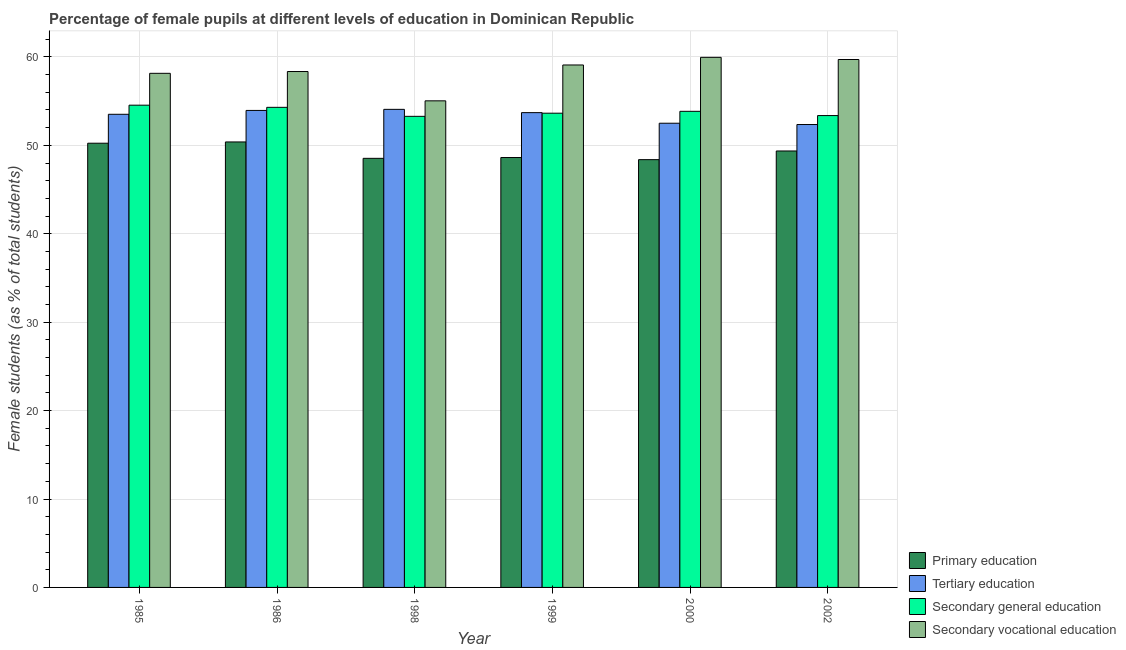How many different coloured bars are there?
Provide a succinct answer. 4. How many groups of bars are there?
Your answer should be very brief. 6. Are the number of bars per tick equal to the number of legend labels?
Ensure brevity in your answer.  Yes. How many bars are there on the 6th tick from the right?
Ensure brevity in your answer.  4. What is the percentage of female students in secondary vocational education in 2000?
Your response must be concise. 59.95. Across all years, what is the maximum percentage of female students in secondary education?
Give a very brief answer. 54.54. Across all years, what is the minimum percentage of female students in secondary vocational education?
Give a very brief answer. 55.03. In which year was the percentage of female students in secondary vocational education maximum?
Ensure brevity in your answer.  2000. In which year was the percentage of female students in tertiary education minimum?
Make the answer very short. 2002. What is the total percentage of female students in secondary education in the graph?
Your answer should be compact. 322.97. What is the difference between the percentage of female students in tertiary education in 1985 and that in 1999?
Your answer should be compact. -0.19. What is the difference between the percentage of female students in secondary vocational education in 2002 and the percentage of female students in primary education in 1999?
Your response must be concise. 0.62. What is the average percentage of female students in tertiary education per year?
Your response must be concise. 53.35. In how many years, is the percentage of female students in tertiary education greater than 24 %?
Offer a terse response. 6. What is the ratio of the percentage of female students in secondary vocational education in 1985 to that in 2000?
Offer a terse response. 0.97. Is the percentage of female students in secondary vocational education in 1985 less than that in 2000?
Offer a very short reply. Yes. What is the difference between the highest and the second highest percentage of female students in secondary education?
Offer a terse response. 0.24. What is the difference between the highest and the lowest percentage of female students in secondary education?
Offer a terse response. 1.26. Is the sum of the percentage of female students in tertiary education in 1998 and 2000 greater than the maximum percentage of female students in primary education across all years?
Offer a terse response. Yes. Is it the case that in every year, the sum of the percentage of female students in secondary education and percentage of female students in primary education is greater than the sum of percentage of female students in secondary vocational education and percentage of female students in tertiary education?
Keep it short and to the point. No. What does the 3rd bar from the left in 1999 represents?
Offer a very short reply. Secondary general education. What does the 1st bar from the right in 2000 represents?
Provide a short and direct response. Secondary vocational education. Is it the case that in every year, the sum of the percentage of female students in primary education and percentage of female students in tertiary education is greater than the percentage of female students in secondary education?
Make the answer very short. Yes. How many years are there in the graph?
Provide a short and direct response. 6. What is the difference between two consecutive major ticks on the Y-axis?
Ensure brevity in your answer.  10. Does the graph contain grids?
Your response must be concise. Yes. Where does the legend appear in the graph?
Your answer should be compact. Bottom right. How many legend labels are there?
Give a very brief answer. 4. How are the legend labels stacked?
Give a very brief answer. Vertical. What is the title of the graph?
Your response must be concise. Percentage of female pupils at different levels of education in Dominican Republic. What is the label or title of the X-axis?
Ensure brevity in your answer.  Year. What is the label or title of the Y-axis?
Your answer should be compact. Female students (as % of total students). What is the Female students (as % of total students) of Primary education in 1985?
Your answer should be compact. 50.24. What is the Female students (as % of total students) of Tertiary education in 1985?
Your answer should be compact. 53.51. What is the Female students (as % of total students) of Secondary general education in 1985?
Your answer should be very brief. 54.54. What is the Female students (as % of total students) in Secondary vocational education in 1985?
Offer a terse response. 58.14. What is the Female students (as % of total students) in Primary education in 1986?
Make the answer very short. 50.38. What is the Female students (as % of total students) of Tertiary education in 1986?
Keep it short and to the point. 53.95. What is the Female students (as % of total students) in Secondary general education in 1986?
Provide a succinct answer. 54.3. What is the Female students (as % of total students) of Secondary vocational education in 1986?
Offer a terse response. 58.35. What is the Female students (as % of total students) of Primary education in 1998?
Offer a very short reply. 48.53. What is the Female students (as % of total students) in Tertiary education in 1998?
Provide a succinct answer. 54.07. What is the Female students (as % of total students) in Secondary general education in 1998?
Your response must be concise. 53.28. What is the Female students (as % of total students) in Secondary vocational education in 1998?
Ensure brevity in your answer.  55.03. What is the Female students (as % of total students) of Primary education in 1999?
Give a very brief answer. 48.62. What is the Female students (as % of total students) in Tertiary education in 1999?
Offer a terse response. 53.7. What is the Female students (as % of total students) of Secondary general education in 1999?
Ensure brevity in your answer.  53.64. What is the Female students (as % of total students) in Secondary vocational education in 1999?
Keep it short and to the point. 59.09. What is the Female students (as % of total students) in Primary education in 2000?
Your response must be concise. 48.38. What is the Female students (as % of total students) in Tertiary education in 2000?
Offer a very short reply. 52.5. What is the Female students (as % of total students) in Secondary general education in 2000?
Your response must be concise. 53.85. What is the Female students (as % of total students) in Secondary vocational education in 2000?
Ensure brevity in your answer.  59.95. What is the Female students (as % of total students) in Primary education in 2002?
Offer a terse response. 49.36. What is the Female students (as % of total students) of Tertiary education in 2002?
Make the answer very short. 52.35. What is the Female students (as % of total students) in Secondary general education in 2002?
Provide a succinct answer. 53.37. What is the Female students (as % of total students) in Secondary vocational education in 2002?
Offer a very short reply. 59.71. Across all years, what is the maximum Female students (as % of total students) of Primary education?
Give a very brief answer. 50.38. Across all years, what is the maximum Female students (as % of total students) of Tertiary education?
Ensure brevity in your answer.  54.07. Across all years, what is the maximum Female students (as % of total students) in Secondary general education?
Provide a succinct answer. 54.54. Across all years, what is the maximum Female students (as % of total students) of Secondary vocational education?
Give a very brief answer. 59.95. Across all years, what is the minimum Female students (as % of total students) in Primary education?
Your answer should be very brief. 48.38. Across all years, what is the minimum Female students (as % of total students) of Tertiary education?
Your answer should be very brief. 52.35. Across all years, what is the minimum Female students (as % of total students) in Secondary general education?
Offer a very short reply. 53.28. Across all years, what is the minimum Female students (as % of total students) of Secondary vocational education?
Your response must be concise. 55.03. What is the total Female students (as % of total students) of Primary education in the graph?
Ensure brevity in your answer.  295.52. What is the total Female students (as % of total students) of Tertiary education in the graph?
Provide a succinct answer. 320.08. What is the total Female students (as % of total students) of Secondary general education in the graph?
Offer a terse response. 322.97. What is the total Female students (as % of total students) of Secondary vocational education in the graph?
Your answer should be compact. 350.27. What is the difference between the Female students (as % of total students) in Primary education in 1985 and that in 1986?
Provide a short and direct response. -0.14. What is the difference between the Female students (as % of total students) in Tertiary education in 1985 and that in 1986?
Give a very brief answer. -0.44. What is the difference between the Female students (as % of total students) in Secondary general education in 1985 and that in 1986?
Offer a terse response. 0.24. What is the difference between the Female students (as % of total students) in Secondary vocational education in 1985 and that in 1986?
Your answer should be very brief. -0.2. What is the difference between the Female students (as % of total students) in Primary education in 1985 and that in 1998?
Your answer should be compact. 1.71. What is the difference between the Female students (as % of total students) of Tertiary education in 1985 and that in 1998?
Make the answer very short. -0.56. What is the difference between the Female students (as % of total students) of Secondary general education in 1985 and that in 1998?
Provide a succinct answer. 1.26. What is the difference between the Female students (as % of total students) of Secondary vocational education in 1985 and that in 1998?
Keep it short and to the point. 3.11. What is the difference between the Female students (as % of total students) of Primary education in 1985 and that in 1999?
Your response must be concise. 1.62. What is the difference between the Female students (as % of total students) in Tertiary education in 1985 and that in 1999?
Provide a succinct answer. -0.19. What is the difference between the Female students (as % of total students) in Secondary general education in 1985 and that in 1999?
Keep it short and to the point. 0.91. What is the difference between the Female students (as % of total students) of Secondary vocational education in 1985 and that in 1999?
Provide a succinct answer. -0.94. What is the difference between the Female students (as % of total students) in Primary education in 1985 and that in 2000?
Your answer should be compact. 1.86. What is the difference between the Female students (as % of total students) of Tertiary education in 1985 and that in 2000?
Offer a very short reply. 1.01. What is the difference between the Female students (as % of total students) in Secondary general education in 1985 and that in 2000?
Offer a very short reply. 0.69. What is the difference between the Female students (as % of total students) in Secondary vocational education in 1985 and that in 2000?
Provide a short and direct response. -1.81. What is the difference between the Female students (as % of total students) of Primary education in 1985 and that in 2002?
Your answer should be very brief. 0.88. What is the difference between the Female students (as % of total students) of Tertiary education in 1985 and that in 2002?
Provide a succinct answer. 1.16. What is the difference between the Female students (as % of total students) of Secondary general education in 1985 and that in 2002?
Provide a short and direct response. 1.18. What is the difference between the Female students (as % of total students) of Secondary vocational education in 1985 and that in 2002?
Provide a succinct answer. -1.56. What is the difference between the Female students (as % of total students) in Primary education in 1986 and that in 1998?
Provide a short and direct response. 1.85. What is the difference between the Female students (as % of total students) of Tertiary education in 1986 and that in 1998?
Ensure brevity in your answer.  -0.12. What is the difference between the Female students (as % of total students) in Secondary general education in 1986 and that in 1998?
Keep it short and to the point. 1.02. What is the difference between the Female students (as % of total students) of Secondary vocational education in 1986 and that in 1998?
Your answer should be compact. 3.32. What is the difference between the Female students (as % of total students) of Primary education in 1986 and that in 1999?
Your answer should be very brief. 1.76. What is the difference between the Female students (as % of total students) of Tertiary education in 1986 and that in 1999?
Give a very brief answer. 0.25. What is the difference between the Female students (as % of total students) in Secondary general education in 1986 and that in 1999?
Offer a very short reply. 0.66. What is the difference between the Female students (as % of total students) in Secondary vocational education in 1986 and that in 1999?
Offer a very short reply. -0.74. What is the difference between the Female students (as % of total students) of Primary education in 1986 and that in 2000?
Keep it short and to the point. 2. What is the difference between the Female students (as % of total students) in Tertiary education in 1986 and that in 2000?
Your answer should be compact. 1.45. What is the difference between the Female students (as % of total students) in Secondary general education in 1986 and that in 2000?
Your response must be concise. 0.45. What is the difference between the Female students (as % of total students) of Secondary vocational education in 1986 and that in 2000?
Ensure brevity in your answer.  -1.6. What is the difference between the Female students (as % of total students) of Primary education in 1986 and that in 2002?
Keep it short and to the point. 1.02. What is the difference between the Female students (as % of total students) of Tertiary education in 1986 and that in 2002?
Offer a very short reply. 1.59. What is the difference between the Female students (as % of total students) of Secondary general education in 1986 and that in 2002?
Your answer should be very brief. 0.93. What is the difference between the Female students (as % of total students) of Secondary vocational education in 1986 and that in 2002?
Your response must be concise. -1.36. What is the difference between the Female students (as % of total students) in Primary education in 1998 and that in 1999?
Keep it short and to the point. -0.09. What is the difference between the Female students (as % of total students) of Tertiary education in 1998 and that in 1999?
Ensure brevity in your answer.  0.37. What is the difference between the Female students (as % of total students) in Secondary general education in 1998 and that in 1999?
Offer a very short reply. -0.36. What is the difference between the Female students (as % of total students) of Secondary vocational education in 1998 and that in 1999?
Give a very brief answer. -4.06. What is the difference between the Female students (as % of total students) of Primary education in 1998 and that in 2000?
Offer a terse response. 0.15. What is the difference between the Female students (as % of total students) in Tertiary education in 1998 and that in 2000?
Provide a short and direct response. 1.57. What is the difference between the Female students (as % of total students) in Secondary general education in 1998 and that in 2000?
Your answer should be compact. -0.57. What is the difference between the Female students (as % of total students) of Secondary vocational education in 1998 and that in 2000?
Offer a very short reply. -4.92. What is the difference between the Female students (as % of total students) of Primary education in 1998 and that in 2002?
Keep it short and to the point. -0.83. What is the difference between the Female students (as % of total students) in Tertiary education in 1998 and that in 2002?
Provide a succinct answer. 1.72. What is the difference between the Female students (as % of total students) in Secondary general education in 1998 and that in 2002?
Your answer should be compact. -0.09. What is the difference between the Female students (as % of total students) of Secondary vocational education in 1998 and that in 2002?
Give a very brief answer. -4.67. What is the difference between the Female students (as % of total students) in Primary education in 1999 and that in 2000?
Give a very brief answer. 0.24. What is the difference between the Female students (as % of total students) in Tertiary education in 1999 and that in 2000?
Offer a terse response. 1.2. What is the difference between the Female students (as % of total students) in Secondary general education in 1999 and that in 2000?
Give a very brief answer. -0.21. What is the difference between the Female students (as % of total students) of Secondary vocational education in 1999 and that in 2000?
Your response must be concise. -0.86. What is the difference between the Female students (as % of total students) in Primary education in 1999 and that in 2002?
Ensure brevity in your answer.  -0.74. What is the difference between the Female students (as % of total students) of Tertiary education in 1999 and that in 2002?
Your response must be concise. 1.34. What is the difference between the Female students (as % of total students) of Secondary general education in 1999 and that in 2002?
Provide a succinct answer. 0.27. What is the difference between the Female students (as % of total students) in Secondary vocational education in 1999 and that in 2002?
Give a very brief answer. -0.62. What is the difference between the Female students (as % of total students) in Primary education in 2000 and that in 2002?
Ensure brevity in your answer.  -0.98. What is the difference between the Female students (as % of total students) of Tertiary education in 2000 and that in 2002?
Your answer should be compact. 0.15. What is the difference between the Female students (as % of total students) of Secondary general education in 2000 and that in 2002?
Provide a succinct answer. 0.48. What is the difference between the Female students (as % of total students) of Secondary vocational education in 2000 and that in 2002?
Provide a succinct answer. 0.25. What is the difference between the Female students (as % of total students) in Primary education in 1985 and the Female students (as % of total students) in Tertiary education in 1986?
Offer a terse response. -3.71. What is the difference between the Female students (as % of total students) of Primary education in 1985 and the Female students (as % of total students) of Secondary general education in 1986?
Provide a short and direct response. -4.06. What is the difference between the Female students (as % of total students) of Primary education in 1985 and the Female students (as % of total students) of Secondary vocational education in 1986?
Provide a succinct answer. -8.11. What is the difference between the Female students (as % of total students) in Tertiary education in 1985 and the Female students (as % of total students) in Secondary general education in 1986?
Provide a succinct answer. -0.79. What is the difference between the Female students (as % of total students) in Tertiary education in 1985 and the Female students (as % of total students) in Secondary vocational education in 1986?
Ensure brevity in your answer.  -4.84. What is the difference between the Female students (as % of total students) in Secondary general education in 1985 and the Female students (as % of total students) in Secondary vocational education in 1986?
Offer a very short reply. -3.81. What is the difference between the Female students (as % of total students) in Primary education in 1985 and the Female students (as % of total students) in Tertiary education in 1998?
Offer a terse response. -3.83. What is the difference between the Female students (as % of total students) of Primary education in 1985 and the Female students (as % of total students) of Secondary general education in 1998?
Provide a short and direct response. -3.04. What is the difference between the Female students (as % of total students) in Primary education in 1985 and the Female students (as % of total students) in Secondary vocational education in 1998?
Ensure brevity in your answer.  -4.79. What is the difference between the Female students (as % of total students) in Tertiary education in 1985 and the Female students (as % of total students) in Secondary general education in 1998?
Your response must be concise. 0.23. What is the difference between the Female students (as % of total students) in Tertiary education in 1985 and the Female students (as % of total students) in Secondary vocational education in 1998?
Keep it short and to the point. -1.52. What is the difference between the Female students (as % of total students) in Secondary general education in 1985 and the Female students (as % of total students) in Secondary vocational education in 1998?
Your answer should be very brief. -0.49. What is the difference between the Female students (as % of total students) in Primary education in 1985 and the Female students (as % of total students) in Tertiary education in 1999?
Ensure brevity in your answer.  -3.46. What is the difference between the Female students (as % of total students) of Primary education in 1985 and the Female students (as % of total students) of Secondary general education in 1999?
Provide a short and direct response. -3.4. What is the difference between the Female students (as % of total students) of Primary education in 1985 and the Female students (as % of total students) of Secondary vocational education in 1999?
Your answer should be very brief. -8.85. What is the difference between the Female students (as % of total students) of Tertiary education in 1985 and the Female students (as % of total students) of Secondary general education in 1999?
Give a very brief answer. -0.12. What is the difference between the Female students (as % of total students) in Tertiary education in 1985 and the Female students (as % of total students) in Secondary vocational education in 1999?
Offer a very short reply. -5.58. What is the difference between the Female students (as % of total students) in Secondary general education in 1985 and the Female students (as % of total students) in Secondary vocational education in 1999?
Your response must be concise. -4.55. What is the difference between the Female students (as % of total students) in Primary education in 1985 and the Female students (as % of total students) in Tertiary education in 2000?
Your response must be concise. -2.26. What is the difference between the Female students (as % of total students) of Primary education in 1985 and the Female students (as % of total students) of Secondary general education in 2000?
Your answer should be compact. -3.61. What is the difference between the Female students (as % of total students) in Primary education in 1985 and the Female students (as % of total students) in Secondary vocational education in 2000?
Your answer should be very brief. -9.71. What is the difference between the Female students (as % of total students) of Tertiary education in 1985 and the Female students (as % of total students) of Secondary general education in 2000?
Your response must be concise. -0.34. What is the difference between the Female students (as % of total students) in Tertiary education in 1985 and the Female students (as % of total students) in Secondary vocational education in 2000?
Give a very brief answer. -6.44. What is the difference between the Female students (as % of total students) in Secondary general education in 1985 and the Female students (as % of total students) in Secondary vocational education in 2000?
Your answer should be very brief. -5.41. What is the difference between the Female students (as % of total students) in Primary education in 1985 and the Female students (as % of total students) in Tertiary education in 2002?
Ensure brevity in your answer.  -2.11. What is the difference between the Female students (as % of total students) of Primary education in 1985 and the Female students (as % of total students) of Secondary general education in 2002?
Ensure brevity in your answer.  -3.13. What is the difference between the Female students (as % of total students) of Primary education in 1985 and the Female students (as % of total students) of Secondary vocational education in 2002?
Keep it short and to the point. -9.47. What is the difference between the Female students (as % of total students) of Tertiary education in 1985 and the Female students (as % of total students) of Secondary general education in 2002?
Make the answer very short. 0.15. What is the difference between the Female students (as % of total students) in Tertiary education in 1985 and the Female students (as % of total students) in Secondary vocational education in 2002?
Your response must be concise. -6.19. What is the difference between the Female students (as % of total students) of Secondary general education in 1985 and the Female students (as % of total students) of Secondary vocational education in 2002?
Your answer should be compact. -5.16. What is the difference between the Female students (as % of total students) in Primary education in 1986 and the Female students (as % of total students) in Tertiary education in 1998?
Keep it short and to the point. -3.69. What is the difference between the Female students (as % of total students) of Primary education in 1986 and the Female students (as % of total students) of Secondary general education in 1998?
Your answer should be compact. -2.9. What is the difference between the Female students (as % of total students) in Primary education in 1986 and the Female students (as % of total students) in Secondary vocational education in 1998?
Make the answer very short. -4.65. What is the difference between the Female students (as % of total students) in Tertiary education in 1986 and the Female students (as % of total students) in Secondary general education in 1998?
Keep it short and to the point. 0.67. What is the difference between the Female students (as % of total students) of Tertiary education in 1986 and the Female students (as % of total students) of Secondary vocational education in 1998?
Your response must be concise. -1.08. What is the difference between the Female students (as % of total students) of Secondary general education in 1986 and the Female students (as % of total students) of Secondary vocational education in 1998?
Make the answer very short. -0.73. What is the difference between the Female students (as % of total students) in Primary education in 1986 and the Female students (as % of total students) in Tertiary education in 1999?
Offer a terse response. -3.32. What is the difference between the Female students (as % of total students) of Primary education in 1986 and the Female students (as % of total students) of Secondary general education in 1999?
Give a very brief answer. -3.25. What is the difference between the Female students (as % of total students) of Primary education in 1986 and the Female students (as % of total students) of Secondary vocational education in 1999?
Make the answer very short. -8.71. What is the difference between the Female students (as % of total students) of Tertiary education in 1986 and the Female students (as % of total students) of Secondary general education in 1999?
Give a very brief answer. 0.31. What is the difference between the Female students (as % of total students) in Tertiary education in 1986 and the Female students (as % of total students) in Secondary vocational education in 1999?
Give a very brief answer. -5.14. What is the difference between the Female students (as % of total students) in Secondary general education in 1986 and the Female students (as % of total students) in Secondary vocational education in 1999?
Offer a terse response. -4.79. What is the difference between the Female students (as % of total students) in Primary education in 1986 and the Female students (as % of total students) in Tertiary education in 2000?
Your response must be concise. -2.12. What is the difference between the Female students (as % of total students) in Primary education in 1986 and the Female students (as % of total students) in Secondary general education in 2000?
Give a very brief answer. -3.46. What is the difference between the Female students (as % of total students) of Primary education in 1986 and the Female students (as % of total students) of Secondary vocational education in 2000?
Offer a very short reply. -9.57. What is the difference between the Female students (as % of total students) in Tertiary education in 1986 and the Female students (as % of total students) in Secondary general education in 2000?
Your response must be concise. 0.1. What is the difference between the Female students (as % of total students) of Tertiary education in 1986 and the Female students (as % of total students) of Secondary vocational education in 2000?
Provide a short and direct response. -6.01. What is the difference between the Female students (as % of total students) in Secondary general education in 1986 and the Female students (as % of total students) in Secondary vocational education in 2000?
Your answer should be very brief. -5.65. What is the difference between the Female students (as % of total students) in Primary education in 1986 and the Female students (as % of total students) in Tertiary education in 2002?
Provide a succinct answer. -1.97. What is the difference between the Female students (as % of total students) in Primary education in 1986 and the Female students (as % of total students) in Secondary general education in 2002?
Keep it short and to the point. -2.98. What is the difference between the Female students (as % of total students) of Primary education in 1986 and the Female students (as % of total students) of Secondary vocational education in 2002?
Offer a terse response. -9.32. What is the difference between the Female students (as % of total students) of Tertiary education in 1986 and the Female students (as % of total students) of Secondary general education in 2002?
Provide a succinct answer. 0.58. What is the difference between the Female students (as % of total students) in Tertiary education in 1986 and the Female students (as % of total students) in Secondary vocational education in 2002?
Provide a short and direct response. -5.76. What is the difference between the Female students (as % of total students) in Secondary general education in 1986 and the Female students (as % of total students) in Secondary vocational education in 2002?
Give a very brief answer. -5.41. What is the difference between the Female students (as % of total students) in Primary education in 1998 and the Female students (as % of total students) in Tertiary education in 1999?
Provide a succinct answer. -5.17. What is the difference between the Female students (as % of total students) of Primary education in 1998 and the Female students (as % of total students) of Secondary general education in 1999?
Your response must be concise. -5.1. What is the difference between the Female students (as % of total students) of Primary education in 1998 and the Female students (as % of total students) of Secondary vocational education in 1999?
Provide a short and direct response. -10.56. What is the difference between the Female students (as % of total students) of Tertiary education in 1998 and the Female students (as % of total students) of Secondary general education in 1999?
Offer a very short reply. 0.44. What is the difference between the Female students (as % of total students) in Tertiary education in 1998 and the Female students (as % of total students) in Secondary vocational education in 1999?
Make the answer very short. -5.02. What is the difference between the Female students (as % of total students) in Secondary general education in 1998 and the Female students (as % of total students) in Secondary vocational education in 1999?
Provide a succinct answer. -5.81. What is the difference between the Female students (as % of total students) in Primary education in 1998 and the Female students (as % of total students) in Tertiary education in 2000?
Offer a very short reply. -3.97. What is the difference between the Female students (as % of total students) of Primary education in 1998 and the Female students (as % of total students) of Secondary general education in 2000?
Offer a terse response. -5.32. What is the difference between the Female students (as % of total students) of Primary education in 1998 and the Female students (as % of total students) of Secondary vocational education in 2000?
Ensure brevity in your answer.  -11.42. What is the difference between the Female students (as % of total students) of Tertiary education in 1998 and the Female students (as % of total students) of Secondary general education in 2000?
Your answer should be very brief. 0.22. What is the difference between the Female students (as % of total students) in Tertiary education in 1998 and the Female students (as % of total students) in Secondary vocational education in 2000?
Make the answer very short. -5.88. What is the difference between the Female students (as % of total students) of Secondary general education in 1998 and the Female students (as % of total students) of Secondary vocational education in 2000?
Give a very brief answer. -6.67. What is the difference between the Female students (as % of total students) of Primary education in 1998 and the Female students (as % of total students) of Tertiary education in 2002?
Your answer should be very brief. -3.82. What is the difference between the Female students (as % of total students) in Primary education in 1998 and the Female students (as % of total students) in Secondary general education in 2002?
Offer a very short reply. -4.84. What is the difference between the Female students (as % of total students) of Primary education in 1998 and the Female students (as % of total students) of Secondary vocational education in 2002?
Provide a succinct answer. -11.18. What is the difference between the Female students (as % of total students) of Tertiary education in 1998 and the Female students (as % of total students) of Secondary general education in 2002?
Your response must be concise. 0.7. What is the difference between the Female students (as % of total students) of Tertiary education in 1998 and the Female students (as % of total students) of Secondary vocational education in 2002?
Keep it short and to the point. -5.64. What is the difference between the Female students (as % of total students) of Secondary general education in 1998 and the Female students (as % of total students) of Secondary vocational education in 2002?
Offer a very short reply. -6.43. What is the difference between the Female students (as % of total students) of Primary education in 1999 and the Female students (as % of total students) of Tertiary education in 2000?
Offer a terse response. -3.88. What is the difference between the Female students (as % of total students) of Primary education in 1999 and the Female students (as % of total students) of Secondary general education in 2000?
Your response must be concise. -5.23. What is the difference between the Female students (as % of total students) of Primary education in 1999 and the Female students (as % of total students) of Secondary vocational education in 2000?
Your response must be concise. -11.33. What is the difference between the Female students (as % of total students) in Tertiary education in 1999 and the Female students (as % of total students) in Secondary general education in 2000?
Your answer should be very brief. -0.15. What is the difference between the Female students (as % of total students) of Tertiary education in 1999 and the Female students (as % of total students) of Secondary vocational education in 2000?
Ensure brevity in your answer.  -6.25. What is the difference between the Female students (as % of total students) in Secondary general education in 1999 and the Female students (as % of total students) in Secondary vocational education in 2000?
Give a very brief answer. -6.32. What is the difference between the Female students (as % of total students) of Primary education in 1999 and the Female students (as % of total students) of Tertiary education in 2002?
Keep it short and to the point. -3.73. What is the difference between the Female students (as % of total students) in Primary education in 1999 and the Female students (as % of total students) in Secondary general education in 2002?
Provide a succinct answer. -4.75. What is the difference between the Female students (as % of total students) in Primary education in 1999 and the Female students (as % of total students) in Secondary vocational education in 2002?
Your answer should be very brief. -11.09. What is the difference between the Female students (as % of total students) of Tertiary education in 1999 and the Female students (as % of total students) of Secondary general education in 2002?
Ensure brevity in your answer.  0.33. What is the difference between the Female students (as % of total students) in Tertiary education in 1999 and the Female students (as % of total students) in Secondary vocational education in 2002?
Give a very brief answer. -6.01. What is the difference between the Female students (as % of total students) in Secondary general education in 1999 and the Female students (as % of total students) in Secondary vocational education in 2002?
Your response must be concise. -6.07. What is the difference between the Female students (as % of total students) of Primary education in 2000 and the Female students (as % of total students) of Tertiary education in 2002?
Ensure brevity in your answer.  -3.97. What is the difference between the Female students (as % of total students) of Primary education in 2000 and the Female students (as % of total students) of Secondary general education in 2002?
Offer a very short reply. -4.98. What is the difference between the Female students (as % of total students) in Primary education in 2000 and the Female students (as % of total students) in Secondary vocational education in 2002?
Offer a very short reply. -11.32. What is the difference between the Female students (as % of total students) of Tertiary education in 2000 and the Female students (as % of total students) of Secondary general education in 2002?
Offer a very short reply. -0.87. What is the difference between the Female students (as % of total students) in Tertiary education in 2000 and the Female students (as % of total students) in Secondary vocational education in 2002?
Your response must be concise. -7.21. What is the difference between the Female students (as % of total students) of Secondary general education in 2000 and the Female students (as % of total students) of Secondary vocational education in 2002?
Provide a short and direct response. -5.86. What is the average Female students (as % of total students) in Primary education per year?
Give a very brief answer. 49.25. What is the average Female students (as % of total students) of Tertiary education per year?
Provide a succinct answer. 53.35. What is the average Female students (as % of total students) of Secondary general education per year?
Provide a short and direct response. 53.83. What is the average Female students (as % of total students) in Secondary vocational education per year?
Your response must be concise. 58.38. In the year 1985, what is the difference between the Female students (as % of total students) of Primary education and Female students (as % of total students) of Tertiary education?
Your response must be concise. -3.27. In the year 1985, what is the difference between the Female students (as % of total students) in Primary education and Female students (as % of total students) in Secondary general education?
Offer a terse response. -4.3. In the year 1985, what is the difference between the Female students (as % of total students) in Primary education and Female students (as % of total students) in Secondary vocational education?
Give a very brief answer. -7.9. In the year 1985, what is the difference between the Female students (as % of total students) in Tertiary education and Female students (as % of total students) in Secondary general education?
Your response must be concise. -1.03. In the year 1985, what is the difference between the Female students (as % of total students) of Tertiary education and Female students (as % of total students) of Secondary vocational education?
Ensure brevity in your answer.  -4.63. In the year 1985, what is the difference between the Female students (as % of total students) of Secondary general education and Female students (as % of total students) of Secondary vocational education?
Provide a short and direct response. -3.6. In the year 1986, what is the difference between the Female students (as % of total students) of Primary education and Female students (as % of total students) of Tertiary education?
Provide a short and direct response. -3.56. In the year 1986, what is the difference between the Female students (as % of total students) in Primary education and Female students (as % of total students) in Secondary general education?
Give a very brief answer. -3.92. In the year 1986, what is the difference between the Female students (as % of total students) of Primary education and Female students (as % of total students) of Secondary vocational education?
Make the answer very short. -7.97. In the year 1986, what is the difference between the Female students (as % of total students) of Tertiary education and Female students (as % of total students) of Secondary general education?
Offer a terse response. -0.35. In the year 1986, what is the difference between the Female students (as % of total students) of Tertiary education and Female students (as % of total students) of Secondary vocational education?
Provide a short and direct response. -4.4. In the year 1986, what is the difference between the Female students (as % of total students) of Secondary general education and Female students (as % of total students) of Secondary vocational education?
Your answer should be very brief. -4.05. In the year 1998, what is the difference between the Female students (as % of total students) of Primary education and Female students (as % of total students) of Tertiary education?
Offer a very short reply. -5.54. In the year 1998, what is the difference between the Female students (as % of total students) in Primary education and Female students (as % of total students) in Secondary general education?
Make the answer very short. -4.75. In the year 1998, what is the difference between the Female students (as % of total students) in Primary education and Female students (as % of total students) in Secondary vocational education?
Provide a succinct answer. -6.5. In the year 1998, what is the difference between the Female students (as % of total students) in Tertiary education and Female students (as % of total students) in Secondary general education?
Make the answer very short. 0.79. In the year 1998, what is the difference between the Female students (as % of total students) of Tertiary education and Female students (as % of total students) of Secondary vocational education?
Keep it short and to the point. -0.96. In the year 1998, what is the difference between the Female students (as % of total students) of Secondary general education and Female students (as % of total students) of Secondary vocational education?
Offer a terse response. -1.75. In the year 1999, what is the difference between the Female students (as % of total students) of Primary education and Female students (as % of total students) of Tertiary education?
Offer a very short reply. -5.08. In the year 1999, what is the difference between the Female students (as % of total students) of Primary education and Female students (as % of total students) of Secondary general education?
Ensure brevity in your answer.  -5.01. In the year 1999, what is the difference between the Female students (as % of total students) of Primary education and Female students (as % of total students) of Secondary vocational education?
Your answer should be very brief. -10.47. In the year 1999, what is the difference between the Female students (as % of total students) in Tertiary education and Female students (as % of total students) in Secondary general education?
Provide a succinct answer. 0.06. In the year 1999, what is the difference between the Female students (as % of total students) in Tertiary education and Female students (as % of total students) in Secondary vocational education?
Offer a very short reply. -5.39. In the year 1999, what is the difference between the Female students (as % of total students) of Secondary general education and Female students (as % of total students) of Secondary vocational education?
Your answer should be very brief. -5.45. In the year 2000, what is the difference between the Female students (as % of total students) in Primary education and Female students (as % of total students) in Tertiary education?
Offer a very short reply. -4.12. In the year 2000, what is the difference between the Female students (as % of total students) in Primary education and Female students (as % of total students) in Secondary general education?
Give a very brief answer. -5.47. In the year 2000, what is the difference between the Female students (as % of total students) of Primary education and Female students (as % of total students) of Secondary vocational education?
Provide a short and direct response. -11.57. In the year 2000, what is the difference between the Female students (as % of total students) in Tertiary education and Female students (as % of total students) in Secondary general education?
Ensure brevity in your answer.  -1.35. In the year 2000, what is the difference between the Female students (as % of total students) of Tertiary education and Female students (as % of total students) of Secondary vocational education?
Your answer should be compact. -7.45. In the year 2000, what is the difference between the Female students (as % of total students) of Secondary general education and Female students (as % of total students) of Secondary vocational education?
Your response must be concise. -6.11. In the year 2002, what is the difference between the Female students (as % of total students) of Primary education and Female students (as % of total students) of Tertiary education?
Your response must be concise. -2.99. In the year 2002, what is the difference between the Female students (as % of total students) in Primary education and Female students (as % of total students) in Secondary general education?
Your answer should be very brief. -4. In the year 2002, what is the difference between the Female students (as % of total students) in Primary education and Female students (as % of total students) in Secondary vocational education?
Your answer should be compact. -10.34. In the year 2002, what is the difference between the Female students (as % of total students) in Tertiary education and Female students (as % of total students) in Secondary general education?
Your answer should be compact. -1.01. In the year 2002, what is the difference between the Female students (as % of total students) in Tertiary education and Female students (as % of total students) in Secondary vocational education?
Provide a succinct answer. -7.35. In the year 2002, what is the difference between the Female students (as % of total students) of Secondary general education and Female students (as % of total students) of Secondary vocational education?
Keep it short and to the point. -6.34. What is the ratio of the Female students (as % of total students) in Secondary general education in 1985 to that in 1986?
Provide a short and direct response. 1. What is the ratio of the Female students (as % of total students) of Primary education in 1985 to that in 1998?
Your response must be concise. 1.04. What is the ratio of the Female students (as % of total students) of Tertiary education in 1985 to that in 1998?
Your answer should be compact. 0.99. What is the ratio of the Female students (as % of total students) of Secondary general education in 1985 to that in 1998?
Provide a succinct answer. 1.02. What is the ratio of the Female students (as % of total students) of Secondary vocational education in 1985 to that in 1998?
Make the answer very short. 1.06. What is the ratio of the Female students (as % of total students) in Secondary general education in 1985 to that in 1999?
Make the answer very short. 1.02. What is the ratio of the Female students (as % of total students) in Secondary vocational education in 1985 to that in 1999?
Give a very brief answer. 0.98. What is the ratio of the Female students (as % of total students) of Primary education in 1985 to that in 2000?
Keep it short and to the point. 1.04. What is the ratio of the Female students (as % of total students) of Tertiary education in 1985 to that in 2000?
Your answer should be compact. 1.02. What is the ratio of the Female students (as % of total students) of Secondary general education in 1985 to that in 2000?
Ensure brevity in your answer.  1.01. What is the ratio of the Female students (as % of total students) of Secondary vocational education in 1985 to that in 2000?
Your answer should be compact. 0.97. What is the ratio of the Female students (as % of total students) of Primary education in 1985 to that in 2002?
Ensure brevity in your answer.  1.02. What is the ratio of the Female students (as % of total students) in Tertiary education in 1985 to that in 2002?
Offer a very short reply. 1.02. What is the ratio of the Female students (as % of total students) of Secondary general education in 1985 to that in 2002?
Your answer should be very brief. 1.02. What is the ratio of the Female students (as % of total students) of Secondary vocational education in 1985 to that in 2002?
Your answer should be very brief. 0.97. What is the ratio of the Female students (as % of total students) of Primary education in 1986 to that in 1998?
Provide a short and direct response. 1.04. What is the ratio of the Female students (as % of total students) in Tertiary education in 1986 to that in 1998?
Offer a terse response. 1. What is the ratio of the Female students (as % of total students) of Secondary general education in 1986 to that in 1998?
Your response must be concise. 1.02. What is the ratio of the Female students (as % of total students) in Secondary vocational education in 1986 to that in 1998?
Provide a succinct answer. 1.06. What is the ratio of the Female students (as % of total students) in Primary education in 1986 to that in 1999?
Provide a short and direct response. 1.04. What is the ratio of the Female students (as % of total students) in Tertiary education in 1986 to that in 1999?
Your answer should be very brief. 1. What is the ratio of the Female students (as % of total students) of Secondary general education in 1986 to that in 1999?
Offer a terse response. 1.01. What is the ratio of the Female students (as % of total students) in Secondary vocational education in 1986 to that in 1999?
Your response must be concise. 0.99. What is the ratio of the Female students (as % of total students) of Primary education in 1986 to that in 2000?
Your response must be concise. 1.04. What is the ratio of the Female students (as % of total students) in Tertiary education in 1986 to that in 2000?
Provide a succinct answer. 1.03. What is the ratio of the Female students (as % of total students) of Secondary general education in 1986 to that in 2000?
Provide a short and direct response. 1.01. What is the ratio of the Female students (as % of total students) in Secondary vocational education in 1986 to that in 2000?
Make the answer very short. 0.97. What is the ratio of the Female students (as % of total students) in Primary education in 1986 to that in 2002?
Your response must be concise. 1.02. What is the ratio of the Female students (as % of total students) in Tertiary education in 1986 to that in 2002?
Ensure brevity in your answer.  1.03. What is the ratio of the Female students (as % of total students) of Secondary general education in 1986 to that in 2002?
Give a very brief answer. 1.02. What is the ratio of the Female students (as % of total students) of Secondary vocational education in 1986 to that in 2002?
Make the answer very short. 0.98. What is the ratio of the Female students (as % of total students) in Secondary vocational education in 1998 to that in 1999?
Keep it short and to the point. 0.93. What is the ratio of the Female students (as % of total students) of Tertiary education in 1998 to that in 2000?
Keep it short and to the point. 1.03. What is the ratio of the Female students (as % of total students) in Secondary general education in 1998 to that in 2000?
Keep it short and to the point. 0.99. What is the ratio of the Female students (as % of total students) of Secondary vocational education in 1998 to that in 2000?
Ensure brevity in your answer.  0.92. What is the ratio of the Female students (as % of total students) in Primary education in 1998 to that in 2002?
Keep it short and to the point. 0.98. What is the ratio of the Female students (as % of total students) in Tertiary education in 1998 to that in 2002?
Ensure brevity in your answer.  1.03. What is the ratio of the Female students (as % of total students) of Secondary vocational education in 1998 to that in 2002?
Your answer should be very brief. 0.92. What is the ratio of the Female students (as % of total students) of Tertiary education in 1999 to that in 2000?
Your answer should be compact. 1.02. What is the ratio of the Female students (as % of total students) of Secondary vocational education in 1999 to that in 2000?
Your response must be concise. 0.99. What is the ratio of the Female students (as % of total students) in Primary education in 1999 to that in 2002?
Offer a very short reply. 0.98. What is the ratio of the Female students (as % of total students) in Tertiary education in 1999 to that in 2002?
Your answer should be very brief. 1.03. What is the ratio of the Female students (as % of total students) of Secondary general education in 1999 to that in 2002?
Give a very brief answer. 1. What is the ratio of the Female students (as % of total students) of Primary education in 2000 to that in 2002?
Ensure brevity in your answer.  0.98. What is the ratio of the Female students (as % of total students) in Tertiary education in 2000 to that in 2002?
Your answer should be compact. 1. What is the ratio of the Female students (as % of total students) in Secondary general education in 2000 to that in 2002?
Give a very brief answer. 1.01. What is the difference between the highest and the second highest Female students (as % of total students) in Primary education?
Provide a short and direct response. 0.14. What is the difference between the highest and the second highest Female students (as % of total students) in Tertiary education?
Give a very brief answer. 0.12. What is the difference between the highest and the second highest Female students (as % of total students) of Secondary general education?
Your answer should be very brief. 0.24. What is the difference between the highest and the second highest Female students (as % of total students) of Secondary vocational education?
Provide a succinct answer. 0.25. What is the difference between the highest and the lowest Female students (as % of total students) of Primary education?
Offer a very short reply. 2. What is the difference between the highest and the lowest Female students (as % of total students) in Tertiary education?
Ensure brevity in your answer.  1.72. What is the difference between the highest and the lowest Female students (as % of total students) in Secondary general education?
Give a very brief answer. 1.26. What is the difference between the highest and the lowest Female students (as % of total students) in Secondary vocational education?
Offer a very short reply. 4.92. 